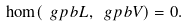<formula> <loc_0><loc_0><loc_500><loc_500>\hom ( \ g p b L , \ g p b V ) = 0 .</formula> 